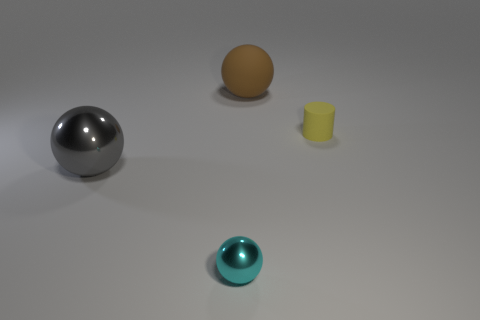Subtract all cyan metallic balls. How many balls are left? 2 Add 2 tiny brown blocks. How many objects exist? 6 Subtract all cyan balls. How many balls are left? 2 Subtract all cylinders. How many objects are left? 3 Subtract 3 spheres. How many spheres are left? 0 Subtract all green cylinders. Subtract all yellow blocks. How many cylinders are left? 1 Subtract all green blocks. How many brown cylinders are left? 0 Subtract all large brown matte objects. Subtract all purple cylinders. How many objects are left? 3 Add 3 cyan balls. How many cyan balls are left? 4 Add 4 tiny red things. How many tiny red things exist? 4 